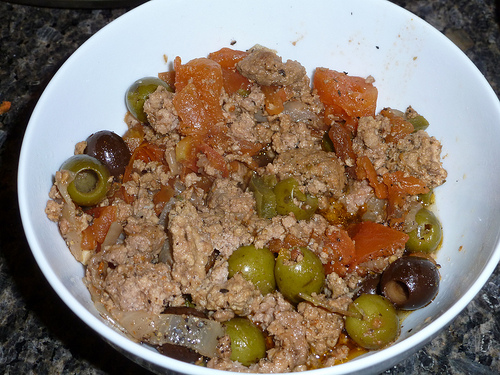<image>
Is the olive under the bowl? No. The olive is not positioned under the bowl. The vertical relationship between these objects is different. Is the bowl above the food? No. The bowl is not positioned above the food. The vertical arrangement shows a different relationship. 